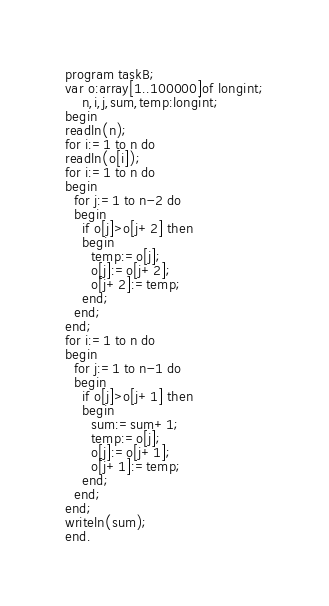<code> <loc_0><loc_0><loc_500><loc_500><_Pascal_>program taskB;
var o:array[1..100000]of longint;
    n,i,j,sum,temp:longint;
begin
readln(n);
for i:=1 to n do
readln(o[i]);
for i:=1 to n do
begin
  for j:=1 to n-2 do
  begin
    if o[j]>o[j+2] then
    begin
      temp:=o[j];
      o[j]:=o[j+2];
      o[j+2]:=temp;
    end;
  end;
end;
for i:=1 to n do
begin
  for j:=1 to n-1 do
  begin
    if o[j]>o[j+1] then
    begin
      sum:=sum+1;
      temp:=o[j];
      o[j]:=o[j+1];
      o[j+1]:=temp;
    end;
  end;
end;
writeln(sum);
end.
</code> 